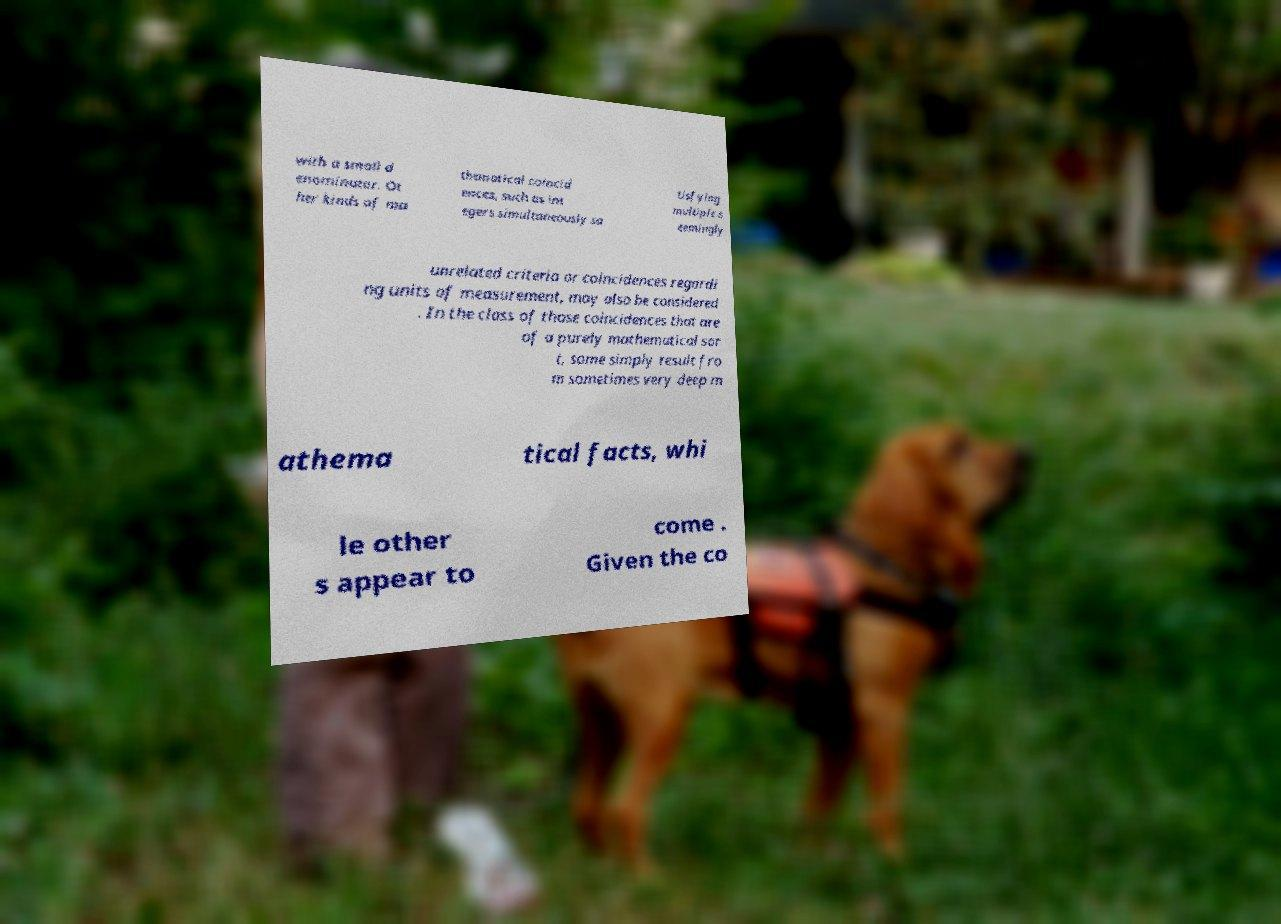Could you assist in decoding the text presented in this image and type it out clearly? with a small d enominator. Ot her kinds of ma thematical coincid ences, such as int egers simultaneously sa tisfying multiple s eemingly unrelated criteria or coincidences regardi ng units of measurement, may also be considered . In the class of those coincidences that are of a purely mathematical sor t, some simply result fro m sometimes very deep m athema tical facts, whi le other s appear to come . Given the co 